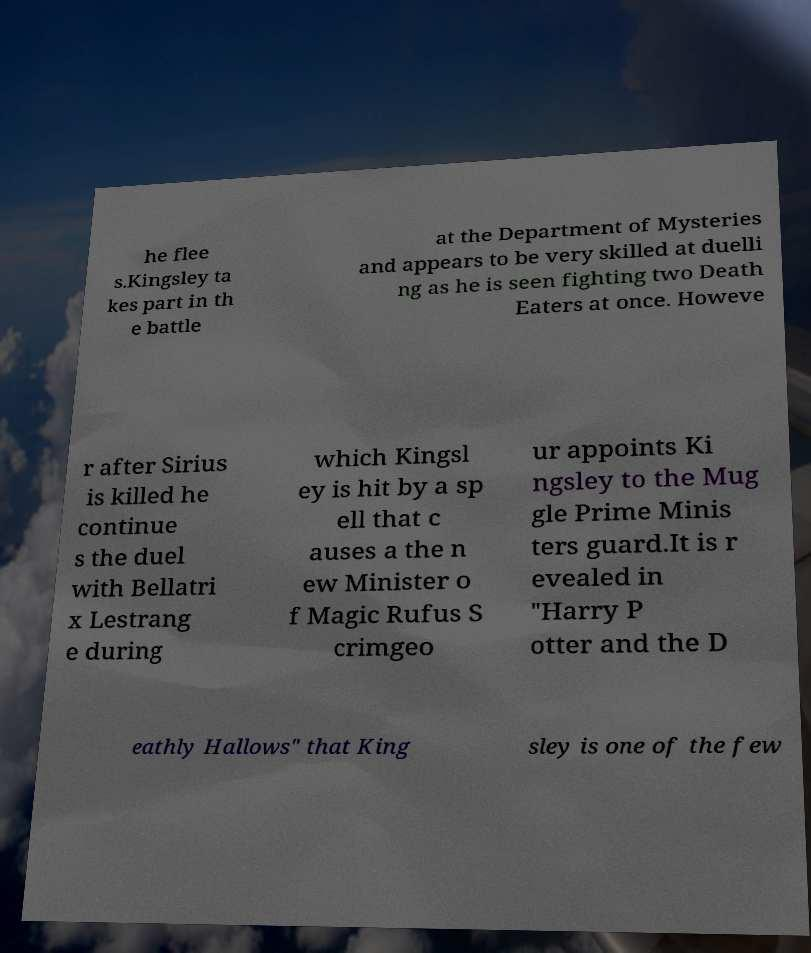There's text embedded in this image that I need extracted. Can you transcribe it verbatim? he flee s.Kingsley ta kes part in th e battle at the Department of Mysteries and appears to be very skilled at duelli ng as he is seen fighting two Death Eaters at once. Howeve r after Sirius is killed he continue s the duel with Bellatri x Lestrang e during which Kingsl ey is hit by a sp ell that c auses a the n ew Minister o f Magic Rufus S crimgeo ur appoints Ki ngsley to the Mug gle Prime Minis ters guard.It is r evealed in "Harry P otter and the D eathly Hallows" that King sley is one of the few 